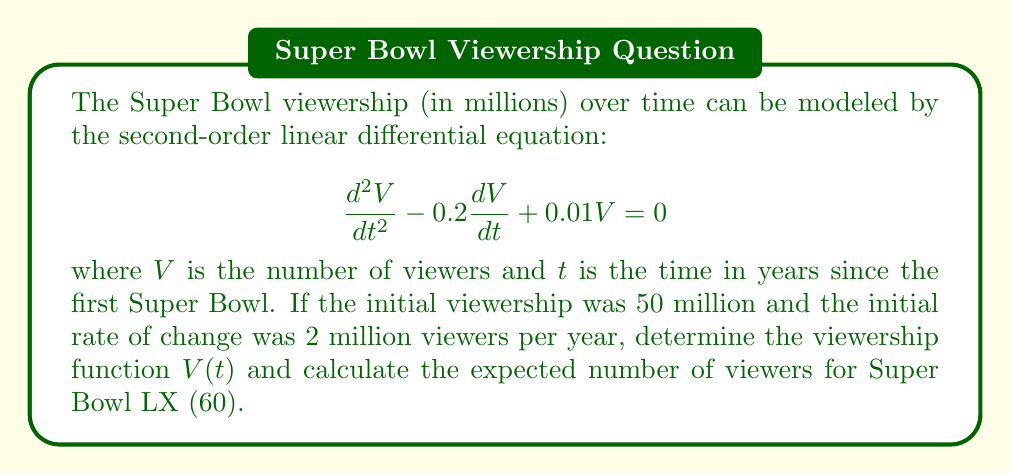Could you help me with this problem? To solve this problem, we'll follow these steps:

1) The characteristic equation for this differential equation is:
   $$r^2 - 0.2r + 0.01 = 0$$

2) Solving this quadratic equation:
   $$r = \frac{0.2 \pm \sqrt{0.04 - 0.04}}{2} = \frac{0.2 \pm 0}{2} = 0.1$$

3) Since we have a repeated root, the general solution is:
   $$V(t) = (C_1 + C_2t)e^{0.1t}$$

4) We're given two initial conditions:
   $V(0) = 50$ (initial viewership)
   $V'(0) = 2$ (initial rate of change)

5) Using the first condition:
   $$50 = C_1$$

6) Taking the derivative of $V(t)$:
   $$V'(t) = (0.1C_1 + C_2 + 0.1C_2t)e^{0.1t}$$

7) Using the second condition:
   $$2 = 0.1C_1 + C_2$$
   $$2 = 0.1(50) + C_2$$
   $$C_2 = 2 - 5 = -3$$

8) Therefore, the viewership function is:
   $$V(t) = (50 - 3t)e^{0.1t}$$

9) To find the viewership for Super Bowl LX, we substitute $t = 60$:
   $$V(60) = (50 - 3(60))e^{0.1(60)} = (50 - 180)e^6 \approx 148.41$$
Answer: The viewership function is $V(t) = (50 - 3t)e^{0.1t}$ million viewers, where $t$ is the number of years since the first Super Bowl. The expected number of viewers for Super Bowl LX (60 years after the first) is approximately 148.41 million. 